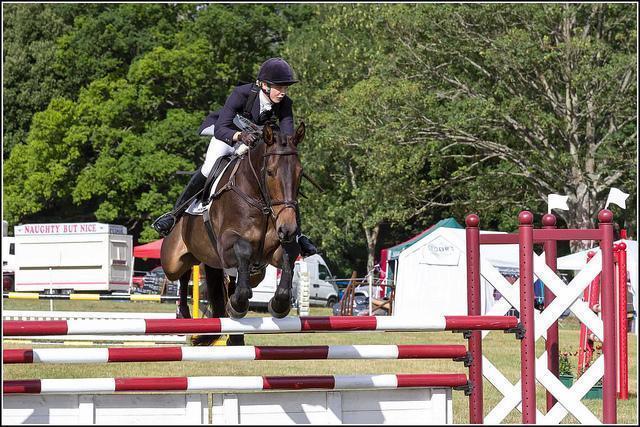What is this sport called?
Answer the question by selecting the correct answer among the 4 following choices and explain your choice with a short sentence. The answer should be formatted with the following format: `Answer: choice
Rationale: rationale.`
Options: Jumping, hurling, vaulting, sailing. Answer: jumping.
Rationale: The woman is on a horse and obviously in some type of competition.  it would appear that jumping is the primary goal of this sport. 